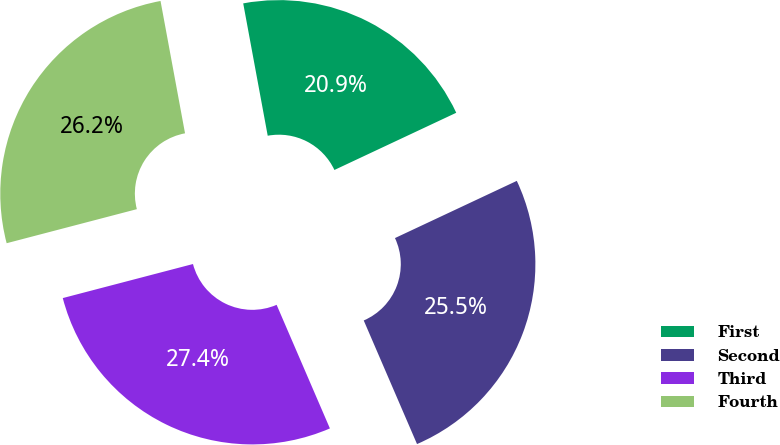Convert chart. <chart><loc_0><loc_0><loc_500><loc_500><pie_chart><fcel>First<fcel>Second<fcel>Third<fcel>Fourth<nl><fcel>20.93%<fcel>25.51%<fcel>27.41%<fcel>26.16%<nl></chart> 